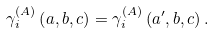<formula> <loc_0><loc_0><loc_500><loc_500>\gamma _ { i } ^ { \left ( A \right ) } \left ( a , b , c \right ) = \gamma _ { i } ^ { \left ( A \right ) } \left ( a ^ { \prime } , b , c \right ) .</formula> 